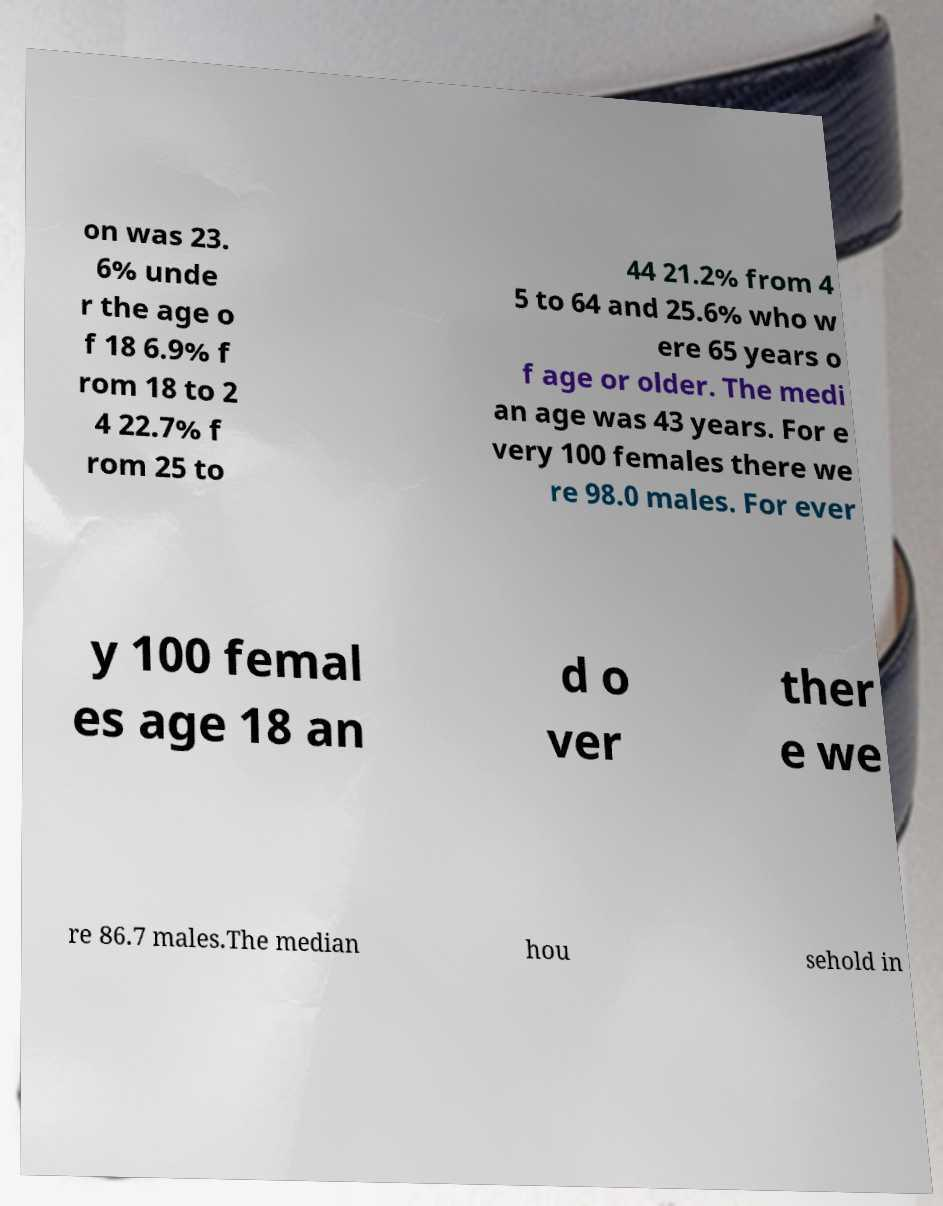What messages or text are displayed in this image? I need them in a readable, typed format. on was 23. 6% unde r the age o f 18 6.9% f rom 18 to 2 4 22.7% f rom 25 to 44 21.2% from 4 5 to 64 and 25.6% who w ere 65 years o f age or older. The medi an age was 43 years. For e very 100 females there we re 98.0 males. For ever y 100 femal es age 18 an d o ver ther e we re 86.7 males.The median hou sehold in 